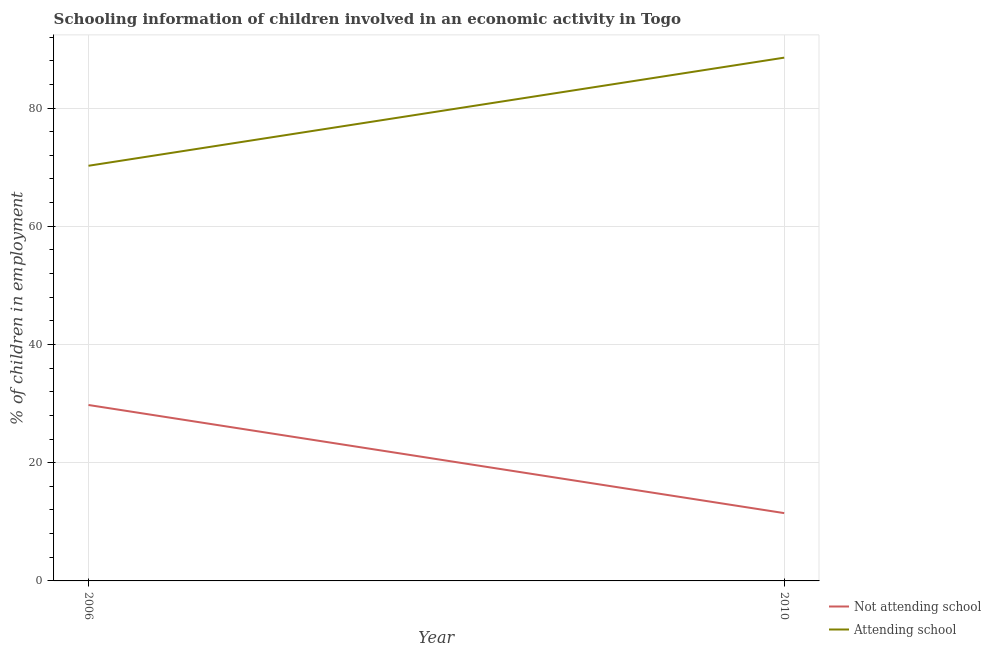Is the number of lines equal to the number of legend labels?
Provide a short and direct response. Yes. What is the percentage of employed children who are not attending school in 2006?
Your answer should be very brief. 29.76. Across all years, what is the maximum percentage of employed children who are attending school?
Your response must be concise. 88.53. Across all years, what is the minimum percentage of employed children who are attending school?
Offer a terse response. 70.24. In which year was the percentage of employed children who are not attending school maximum?
Make the answer very short. 2006. What is the total percentage of employed children who are not attending school in the graph?
Your response must be concise. 41.23. What is the difference between the percentage of employed children who are attending school in 2006 and that in 2010?
Your answer should be compact. -18.29. What is the difference between the percentage of employed children who are attending school in 2006 and the percentage of employed children who are not attending school in 2010?
Your answer should be compact. 58.77. What is the average percentage of employed children who are not attending school per year?
Keep it short and to the point. 20.62. In the year 2006, what is the difference between the percentage of employed children who are not attending school and percentage of employed children who are attending school?
Your answer should be very brief. -40.47. In how many years, is the percentage of employed children who are not attending school greater than 64 %?
Your answer should be compact. 0. What is the ratio of the percentage of employed children who are not attending school in 2006 to that in 2010?
Make the answer very short. 2.59. In how many years, is the percentage of employed children who are not attending school greater than the average percentage of employed children who are not attending school taken over all years?
Offer a terse response. 1. Is the percentage of employed children who are not attending school strictly less than the percentage of employed children who are attending school over the years?
Your response must be concise. Yes. What is the difference between two consecutive major ticks on the Y-axis?
Give a very brief answer. 20. Are the values on the major ticks of Y-axis written in scientific E-notation?
Offer a terse response. No. Does the graph contain any zero values?
Provide a succinct answer. No. How many legend labels are there?
Your response must be concise. 2. How are the legend labels stacked?
Your answer should be very brief. Vertical. What is the title of the graph?
Offer a very short reply. Schooling information of children involved in an economic activity in Togo. Does "International Tourists" appear as one of the legend labels in the graph?
Offer a terse response. No. What is the label or title of the X-axis?
Provide a short and direct response. Year. What is the label or title of the Y-axis?
Provide a succinct answer. % of children in employment. What is the % of children in employment in Not attending school in 2006?
Your answer should be very brief. 29.76. What is the % of children in employment of Attending school in 2006?
Ensure brevity in your answer.  70.24. What is the % of children in employment in Not attending school in 2010?
Your answer should be very brief. 11.47. What is the % of children in employment in Attending school in 2010?
Your answer should be very brief. 88.53. Across all years, what is the maximum % of children in employment in Not attending school?
Keep it short and to the point. 29.76. Across all years, what is the maximum % of children in employment in Attending school?
Give a very brief answer. 88.53. Across all years, what is the minimum % of children in employment in Not attending school?
Offer a very short reply. 11.47. Across all years, what is the minimum % of children in employment in Attending school?
Provide a short and direct response. 70.24. What is the total % of children in employment of Not attending school in the graph?
Make the answer very short. 41.23. What is the total % of children in employment in Attending school in the graph?
Keep it short and to the point. 158.77. What is the difference between the % of children in employment of Not attending school in 2006 and that in 2010?
Your response must be concise. 18.29. What is the difference between the % of children in employment in Attending school in 2006 and that in 2010?
Give a very brief answer. -18.29. What is the difference between the % of children in employment in Not attending school in 2006 and the % of children in employment in Attending school in 2010?
Keep it short and to the point. -58.77. What is the average % of children in employment of Not attending school per year?
Your response must be concise. 20.62. What is the average % of children in employment of Attending school per year?
Provide a succinct answer. 79.38. In the year 2006, what is the difference between the % of children in employment in Not attending school and % of children in employment in Attending school?
Your response must be concise. -40.47. In the year 2010, what is the difference between the % of children in employment of Not attending school and % of children in employment of Attending school?
Make the answer very short. -77.06. What is the ratio of the % of children in employment of Not attending school in 2006 to that in 2010?
Provide a succinct answer. 2.59. What is the ratio of the % of children in employment of Attending school in 2006 to that in 2010?
Ensure brevity in your answer.  0.79. What is the difference between the highest and the second highest % of children in employment of Not attending school?
Your response must be concise. 18.29. What is the difference between the highest and the second highest % of children in employment of Attending school?
Your answer should be compact. 18.29. What is the difference between the highest and the lowest % of children in employment of Not attending school?
Ensure brevity in your answer.  18.29. What is the difference between the highest and the lowest % of children in employment in Attending school?
Keep it short and to the point. 18.29. 